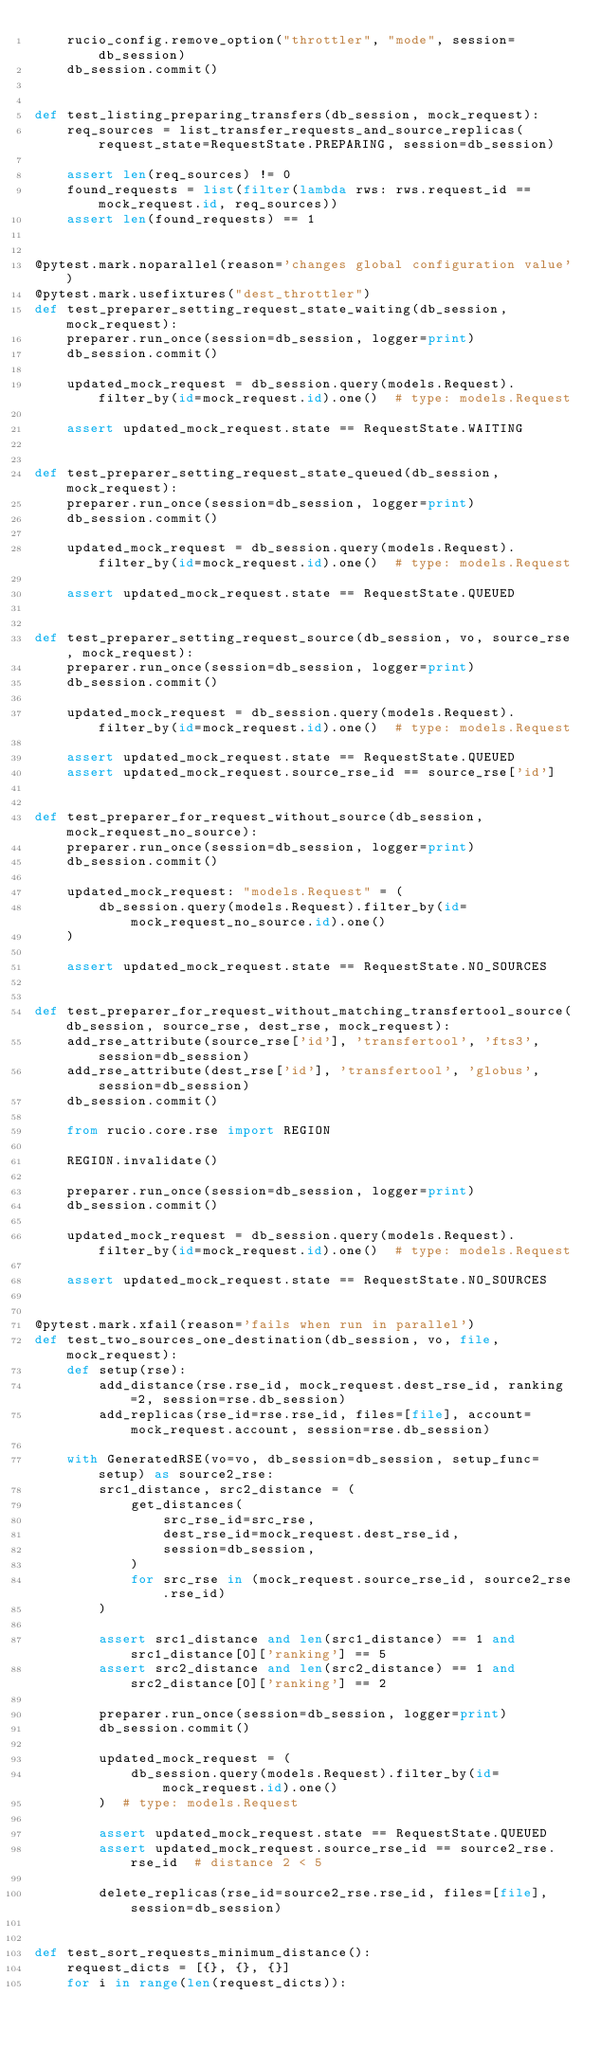Convert code to text. <code><loc_0><loc_0><loc_500><loc_500><_Python_>    rucio_config.remove_option("throttler", "mode", session=db_session)
    db_session.commit()


def test_listing_preparing_transfers(db_session, mock_request):
    req_sources = list_transfer_requests_and_source_replicas(request_state=RequestState.PREPARING, session=db_session)

    assert len(req_sources) != 0
    found_requests = list(filter(lambda rws: rws.request_id == mock_request.id, req_sources))
    assert len(found_requests) == 1


@pytest.mark.noparallel(reason='changes global configuration value')
@pytest.mark.usefixtures("dest_throttler")
def test_preparer_setting_request_state_waiting(db_session, mock_request):
    preparer.run_once(session=db_session, logger=print)
    db_session.commit()

    updated_mock_request = db_session.query(models.Request).filter_by(id=mock_request.id).one()  # type: models.Request

    assert updated_mock_request.state == RequestState.WAITING


def test_preparer_setting_request_state_queued(db_session, mock_request):
    preparer.run_once(session=db_session, logger=print)
    db_session.commit()

    updated_mock_request = db_session.query(models.Request).filter_by(id=mock_request.id).one()  # type: models.Request

    assert updated_mock_request.state == RequestState.QUEUED


def test_preparer_setting_request_source(db_session, vo, source_rse, mock_request):
    preparer.run_once(session=db_session, logger=print)
    db_session.commit()

    updated_mock_request = db_session.query(models.Request).filter_by(id=mock_request.id).one()  # type: models.Request

    assert updated_mock_request.state == RequestState.QUEUED
    assert updated_mock_request.source_rse_id == source_rse['id']


def test_preparer_for_request_without_source(db_session, mock_request_no_source):
    preparer.run_once(session=db_session, logger=print)
    db_session.commit()

    updated_mock_request: "models.Request" = (
        db_session.query(models.Request).filter_by(id=mock_request_no_source.id).one()
    )

    assert updated_mock_request.state == RequestState.NO_SOURCES


def test_preparer_for_request_without_matching_transfertool_source(db_session, source_rse, dest_rse, mock_request):
    add_rse_attribute(source_rse['id'], 'transfertool', 'fts3', session=db_session)
    add_rse_attribute(dest_rse['id'], 'transfertool', 'globus', session=db_session)
    db_session.commit()

    from rucio.core.rse import REGION

    REGION.invalidate()

    preparer.run_once(session=db_session, logger=print)
    db_session.commit()

    updated_mock_request = db_session.query(models.Request).filter_by(id=mock_request.id).one()  # type: models.Request

    assert updated_mock_request.state == RequestState.NO_SOURCES


@pytest.mark.xfail(reason='fails when run in parallel')
def test_two_sources_one_destination(db_session, vo, file, mock_request):
    def setup(rse):
        add_distance(rse.rse_id, mock_request.dest_rse_id, ranking=2, session=rse.db_session)
        add_replicas(rse_id=rse.rse_id, files=[file], account=mock_request.account, session=rse.db_session)

    with GeneratedRSE(vo=vo, db_session=db_session, setup_func=setup) as source2_rse:
        src1_distance, src2_distance = (
            get_distances(
                src_rse_id=src_rse,
                dest_rse_id=mock_request.dest_rse_id,
                session=db_session,
            )
            for src_rse in (mock_request.source_rse_id, source2_rse.rse_id)
        )

        assert src1_distance and len(src1_distance) == 1 and src1_distance[0]['ranking'] == 5
        assert src2_distance and len(src2_distance) == 1 and src2_distance[0]['ranking'] == 2

        preparer.run_once(session=db_session, logger=print)
        db_session.commit()

        updated_mock_request = (
            db_session.query(models.Request).filter_by(id=mock_request.id).one()
        )  # type: models.Request

        assert updated_mock_request.state == RequestState.QUEUED
        assert updated_mock_request.source_rse_id == source2_rse.rse_id  # distance 2 < 5

        delete_replicas(rse_id=source2_rse.rse_id, files=[file], session=db_session)


def test_sort_requests_minimum_distance():
    request_dicts = [{}, {}, {}]
    for i in range(len(request_dicts)):</code> 